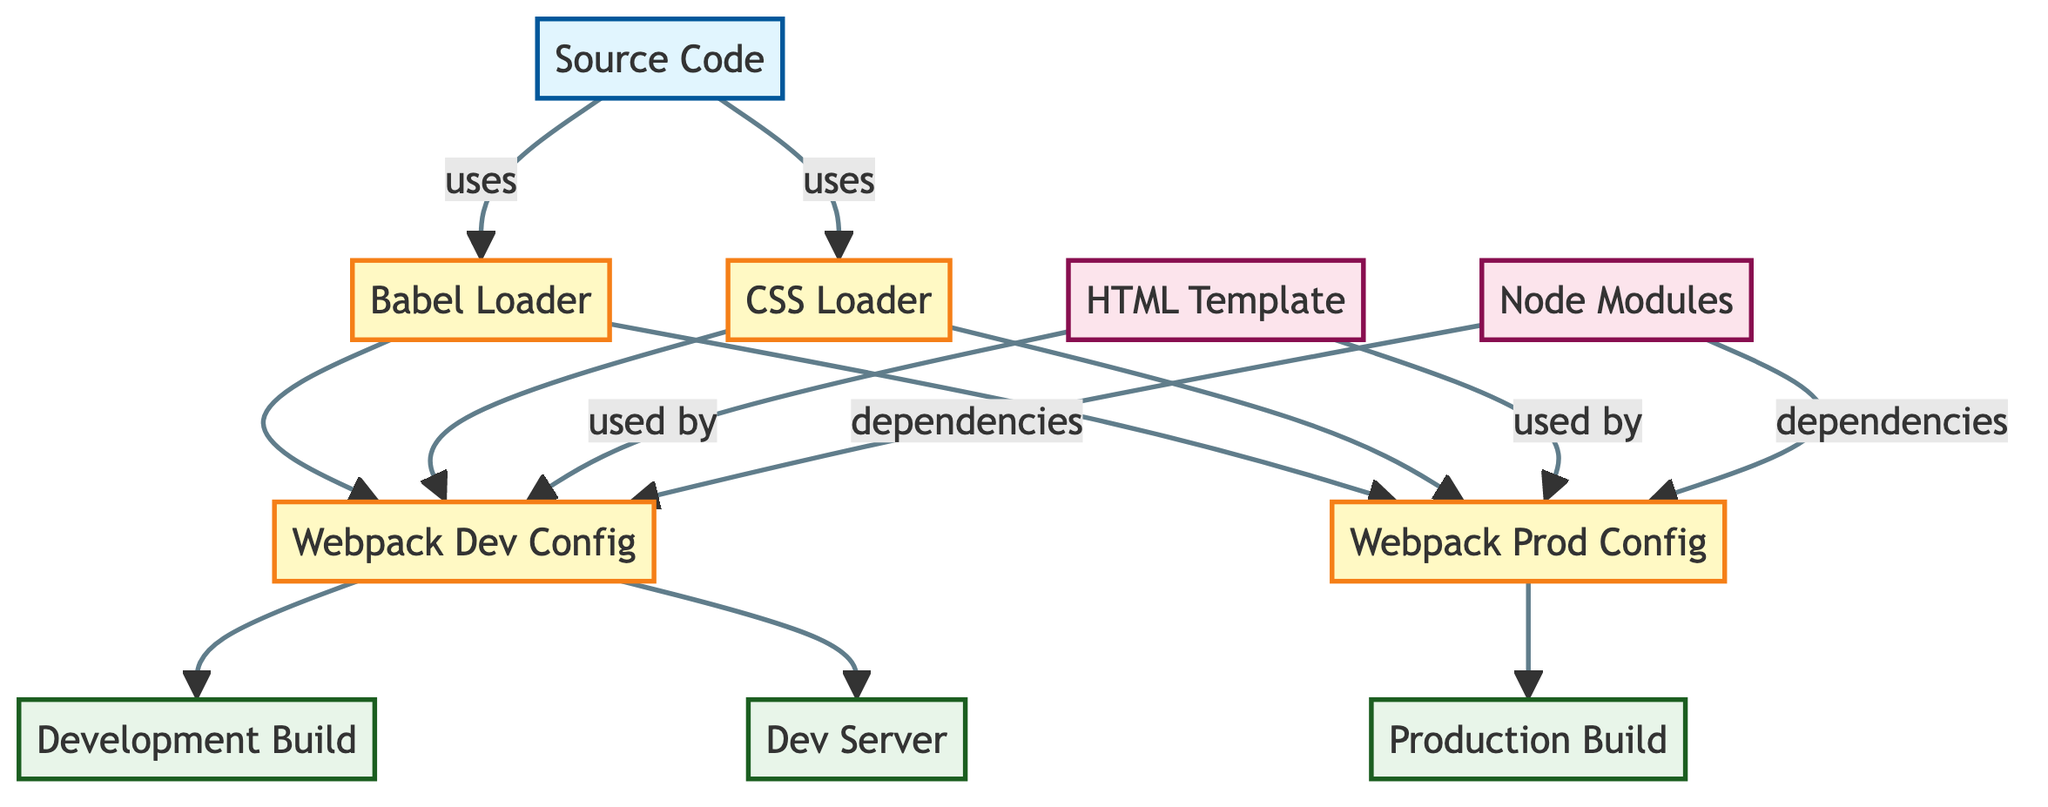What is the type of the node labeled "Source Code"? The node labeled "Source Code" is classified as an "input" type node, which is indicated in the diagram's classification system.
Answer: input How many output nodes are present in the diagram? By counting the nodes that are classified as outputs, we find three output nodes: "Dev Server," "Development Build," and "Production Build."
Answer: 3 Which process is connected to the node labeled "Dev Server"? The "Dev Server" node is directly connected to the "Webpack Dev Config" node. This relationship shows that the development configuration is utilized to serve the build.
Answer: Webpack Dev Config What are the dependencies for the "Webpack Prod Config"? The "Webpack Prod Config" has two dependencies: "Node Modules" and "HTML Template" as indicated by the edges showing a relationship of 'dependencies' and 'used by'.
Answer: Node Modules, HTML Template Which loader is used by both the development and production builds? Both the "Babel Loader" and "CSS Loader" are used in conjunction with the "Webpack Dev Config" and "Webpack Prod Config" as reflected by the edges connecting them to both process nodes.
Answer: Babel Loader, CSS Loader How many nodes are classified as resources in the diagram? The diagram displays two resource nodes: "HTML Template" and "Node Modules," thus, the count of resource nodes is two.
Answer: 2 Which configuration file leads directly to the "Production Build"? The "Webpack Prod Config" is the configuration file that directly leads to the "Production Build" node, indicating the process flow for building production-level output.
Answer: Webpack Prod Config What relationship exists between "Source Code" and "Babel Loader"? The relationship between "Source Code" and "Babel Loader" is that "Source Code" uses "Babel Loader," suggesting that it relies on this loader for handling its code transpilation.
Answer: uses Which node serves the "Development Build"? The "Dev Server" node serves the "Development Build," as shown by the connection from "Webpack Dev Config" to "Dev Server." This indicates that the development build is being served by the dev server.
Answer: Dev Server 